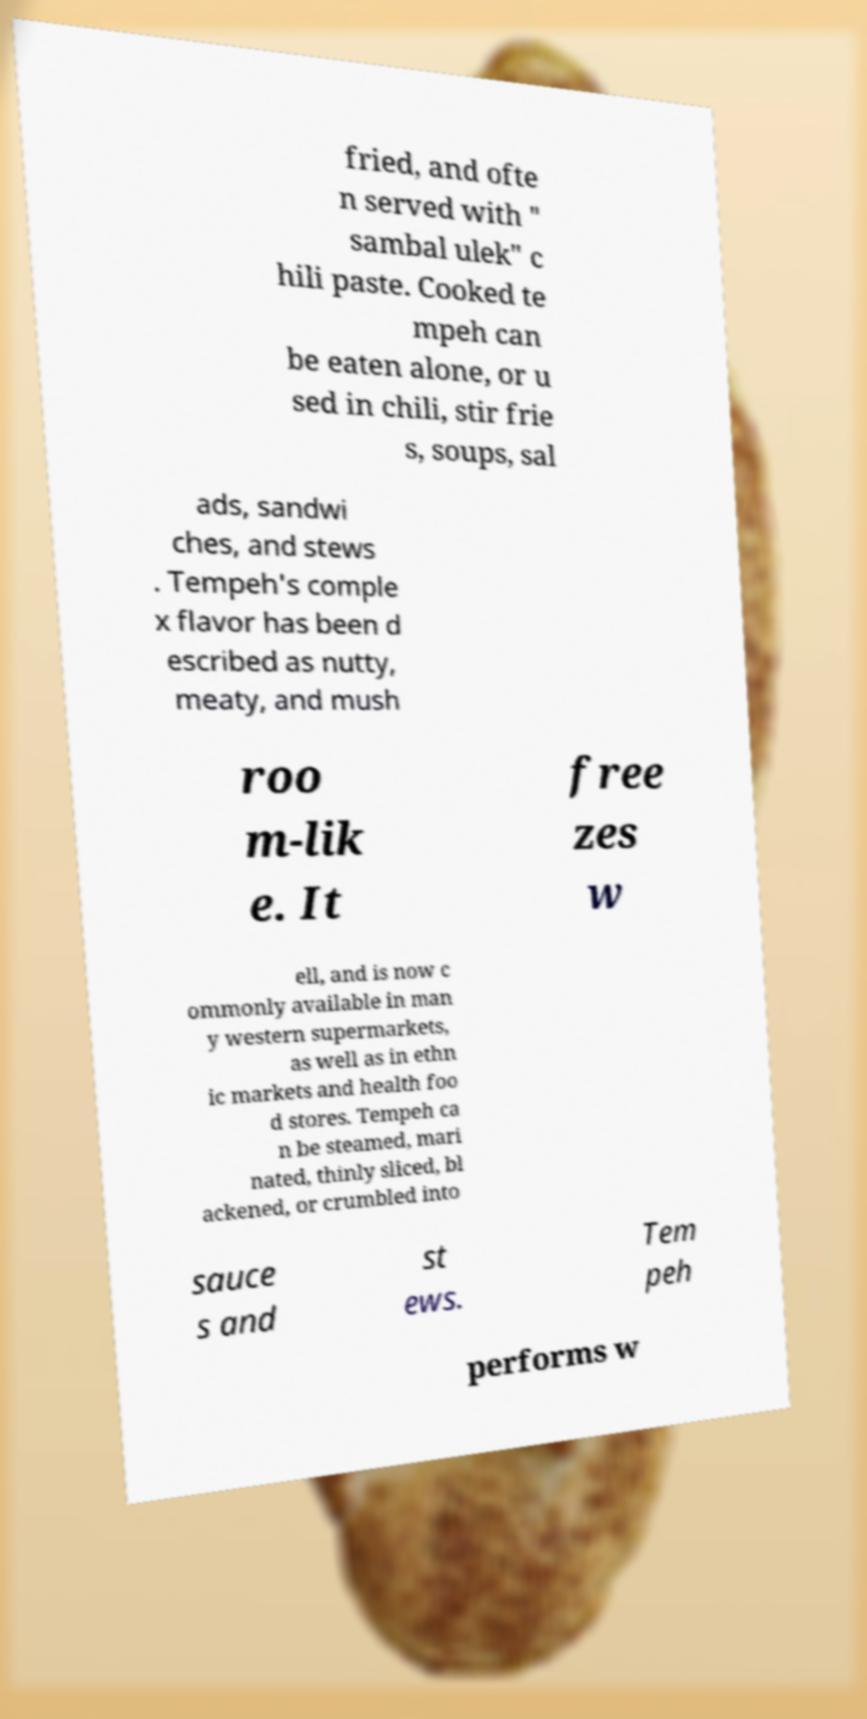For documentation purposes, I need the text within this image transcribed. Could you provide that? fried, and ofte n served with " sambal ulek" c hili paste. Cooked te mpeh can be eaten alone, or u sed in chili, stir frie s, soups, sal ads, sandwi ches, and stews . Tempeh's comple x flavor has been d escribed as nutty, meaty, and mush roo m-lik e. It free zes w ell, and is now c ommonly available in man y western supermarkets, as well as in ethn ic markets and health foo d stores. Tempeh ca n be steamed, mari nated, thinly sliced, bl ackened, or crumbled into sauce s and st ews. Tem peh performs w 